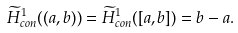<formula> <loc_0><loc_0><loc_500><loc_500>\widetilde { H } ^ { 1 } _ { c o n } ( ( a , b ) ) = \widetilde { H } ^ { 1 } _ { c o n } ( [ a , b ] ) = b - a .</formula> 